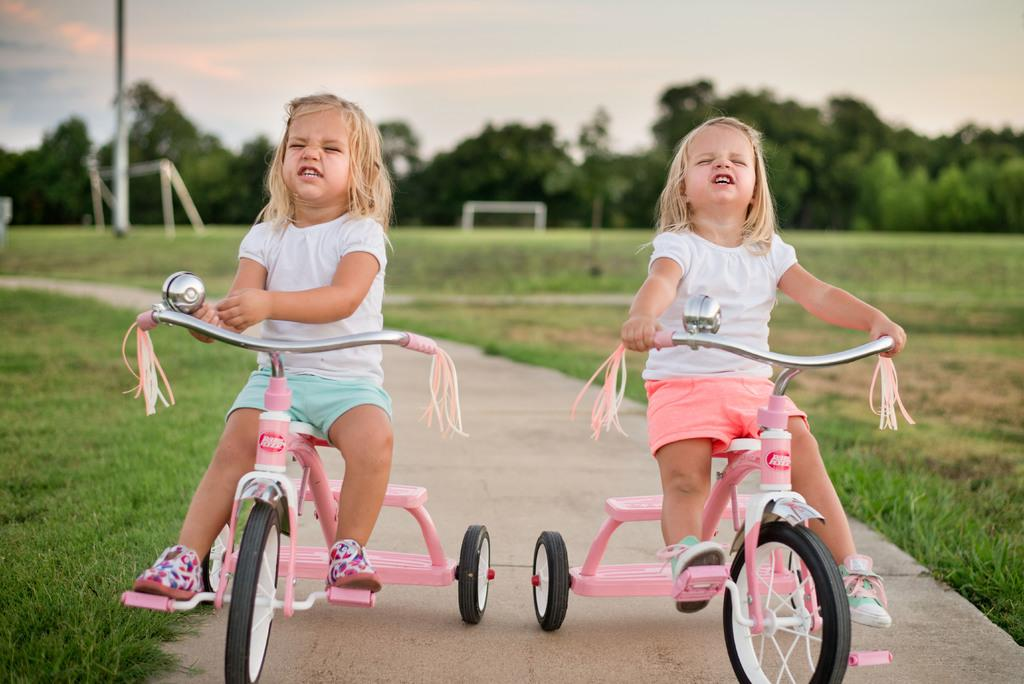How many kids are in the image? There are two kids in the image. What are the kids doing in the image? The kids are riding a bicycle. What can be seen in the distance in the image? There are trees in the distance. What is the color of the grass in the image? The grass is green in color. What type of vest is the bicycle wearing in the image? The bicycle is not wearing a vest, as it is an inanimate object and cannot wear clothing. Can you see any orange objects in the image? There is no mention of any orange objects in the provided facts, so it cannot be determined if any are present in the image. 